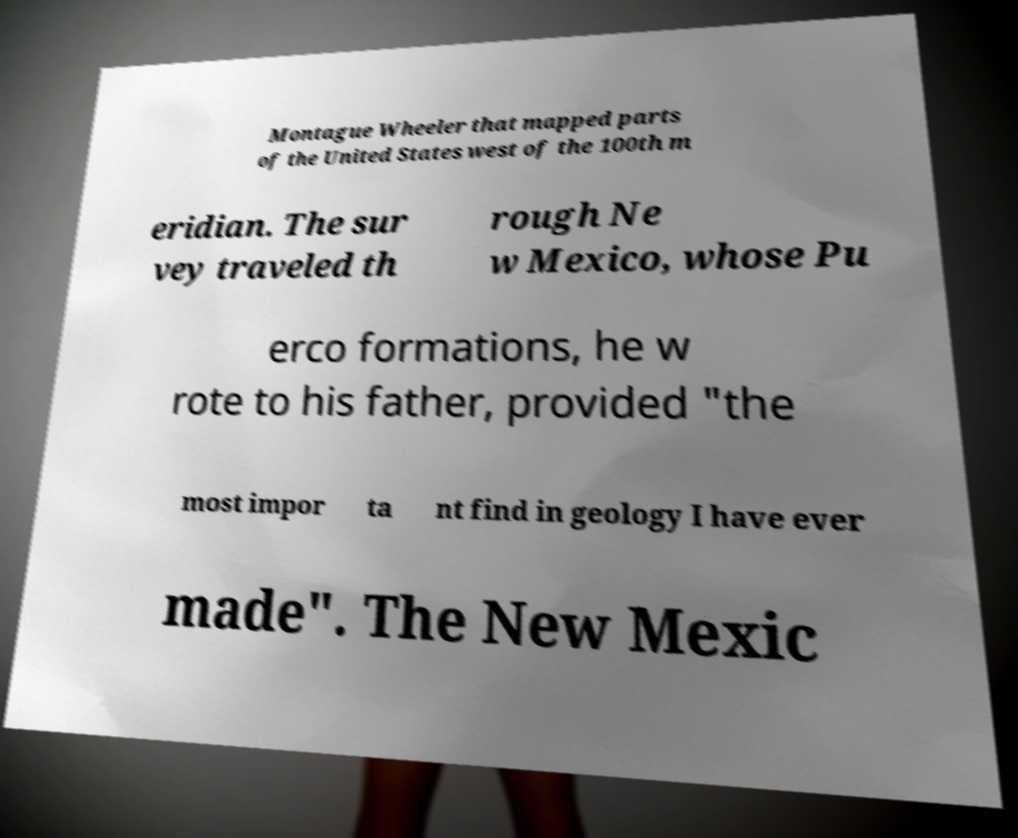Could you extract and type out the text from this image? Montague Wheeler that mapped parts of the United States west of the 100th m eridian. The sur vey traveled th rough Ne w Mexico, whose Pu erco formations, he w rote to his father, provided "the most impor ta nt find in geology I have ever made". The New Mexic 